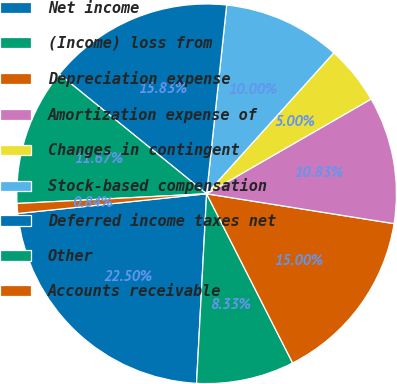<chart> <loc_0><loc_0><loc_500><loc_500><pie_chart><fcel>Net income<fcel>(Income) loss from<fcel>Depreciation expense<fcel>Amortization expense of<fcel>Changes in contingent<fcel>Stock-based compensation<fcel>Deferred income taxes net<fcel>Other<fcel>Accounts receivable<nl><fcel>22.5%<fcel>8.33%<fcel>15.0%<fcel>10.83%<fcel>5.0%<fcel>10.0%<fcel>15.83%<fcel>11.67%<fcel>0.84%<nl></chart> 